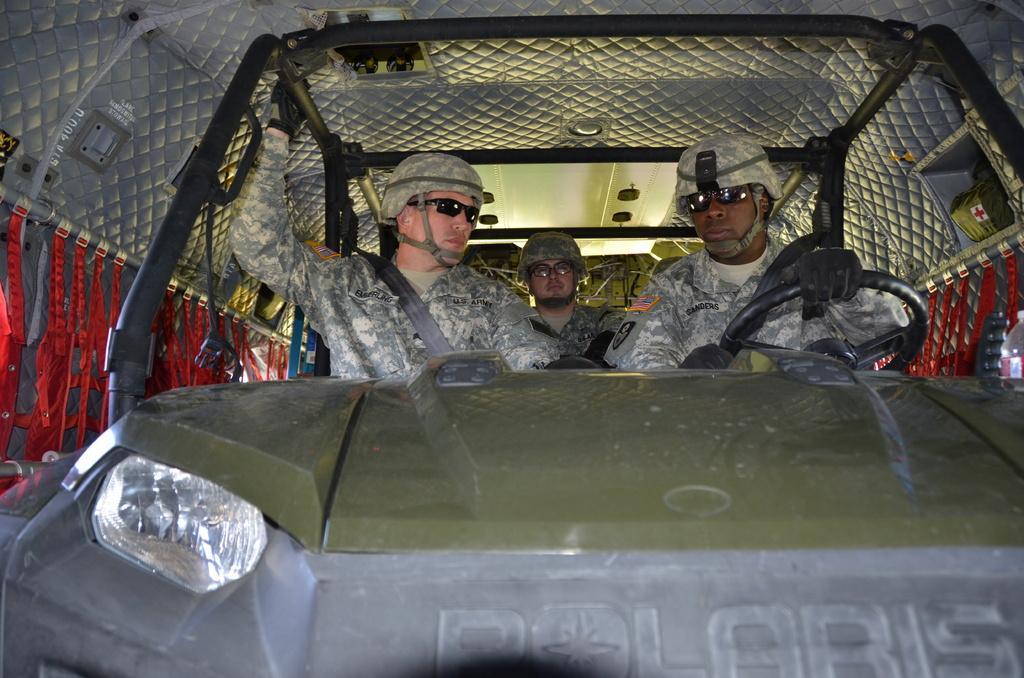Can you describe this image briefly? In the picture I can see this three persons wearing army uniforms, helmets and glasses are sitting in the car which is inside another vehicle. 